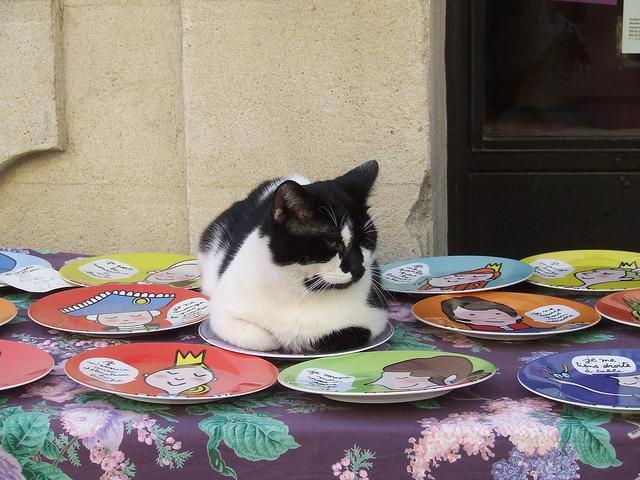How many plates?
Give a very brief answer. 13. How many people are holding camera?
Give a very brief answer. 0. 